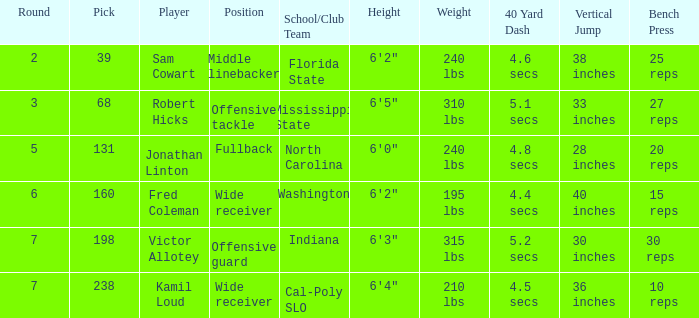Which Round has a School/Club Team of indiana, and a Pick smaller than 198? None. 